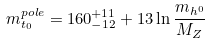<formula> <loc_0><loc_0><loc_500><loc_500>m _ { t _ { 0 } } ^ { p o l e } = 1 6 0 ^ { + 1 1 } _ { - 1 2 } + 1 3 \ln { \frac { m _ { h ^ { 0 } } } { M _ { Z } } }</formula> 